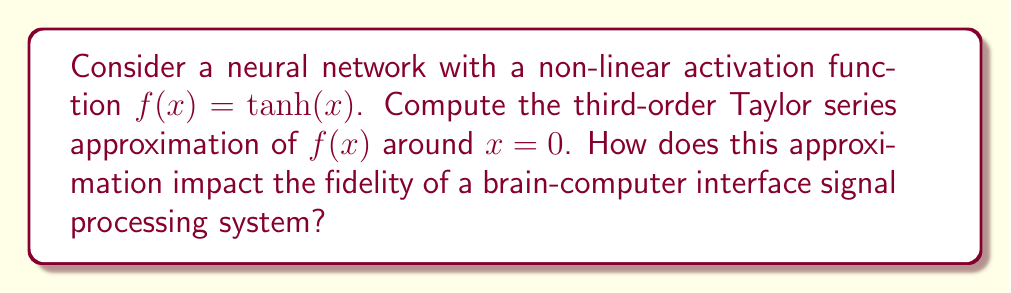Teach me how to tackle this problem. To compute the Taylor series approximation, we follow these steps:

1) The general form of a third-order Taylor series around $x = 0$ is:

   $$f(x) \approx f(0) + f'(0)x + \frac{f''(0)}{2!}x^2 + \frac{f'''(0)}{3!}x^3$$

2) We need to calculate $f(0)$, $f'(0)$, $f''(0)$, and $f'''(0)$:

   $f(x) = \tanh(x)$
   $f'(x) = \text{sech}^2(x)$
   $f''(x) = -2\tanh(x)\text{sech}^2(x)$
   $f'''(x) = -2\text{sech}^2(x)(1-3\tanh^2(x))$

3) Evaluating at $x = 0$:

   $f(0) = \tanh(0) = 0$
   $f'(0) = \text{sech}^2(0) = 1$
   $f''(0) = -2\tanh(0)\text{sech}^2(0) = 0$
   $f'''(0) = -2\text{sech}^2(0)(1-3\tanh^2(0)) = -2$

4) Substituting into the Taylor series:

   $$f(x) \approx 0 + x + 0 + \frac{-2}{3!}x^3 = x - \frac{1}{3}x^3$$

5) Impact on brain-computer interface fidelity:

   This approximation simplifies the non-linear activation function, which can reduce computational complexity in the signal processing system. However, it introduces an approximation error, especially for larger input values. In a brain-computer interface, this could lead to reduced accuracy in interpreting neural signals, particularly for stronger or more complex patterns. The trade-off between computational efficiency and signal fidelity would need to be carefully considered based on the specific requirements of the brain-computer interface system.
Answer: $x - \frac{1}{3}x^3$ 